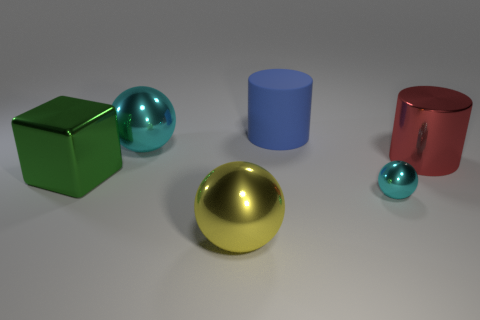Add 4 yellow objects. How many objects exist? 10 Subtract all cyan shiny balls. How many balls are left? 1 Subtract all yellow spheres. How many spheres are left? 2 Subtract all cylinders. How many objects are left? 4 Subtract all brown cylinders. How many yellow balls are left? 1 Subtract all large red things. Subtract all cylinders. How many objects are left? 3 Add 2 yellow balls. How many yellow balls are left? 3 Add 6 large blue cylinders. How many large blue cylinders exist? 7 Subtract 0 gray balls. How many objects are left? 6 Subtract all green spheres. Subtract all brown cubes. How many spheres are left? 3 